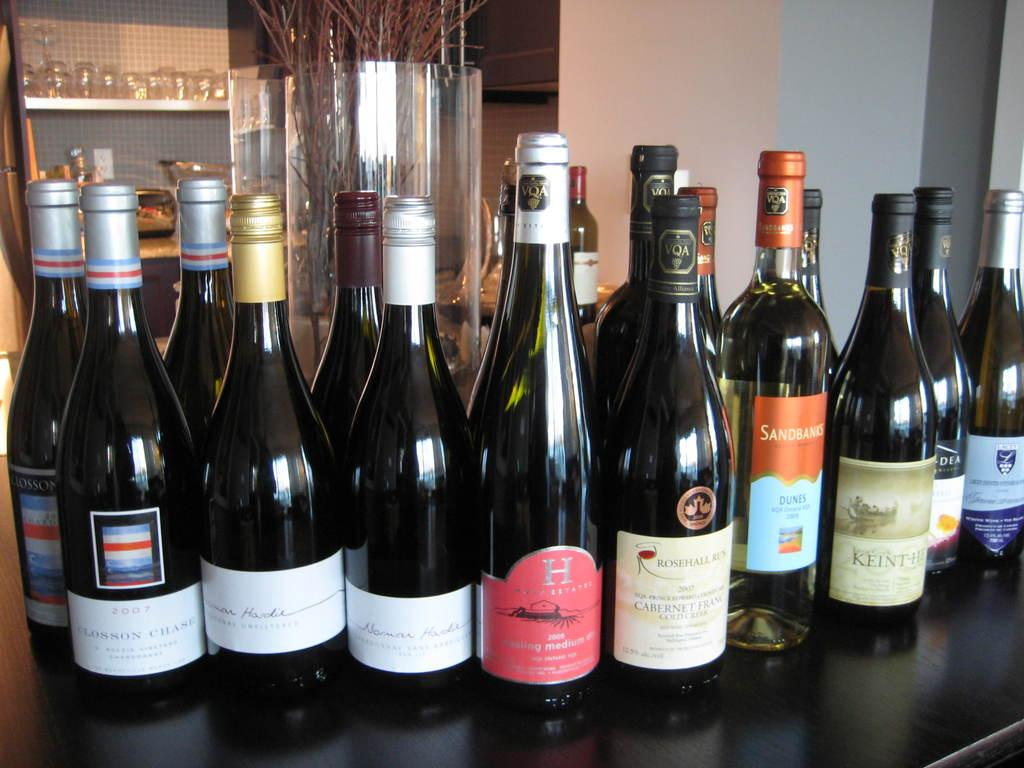Provide a one-sentence caption for the provided image. Bottles of wine with one that has a giant letter H on it. 